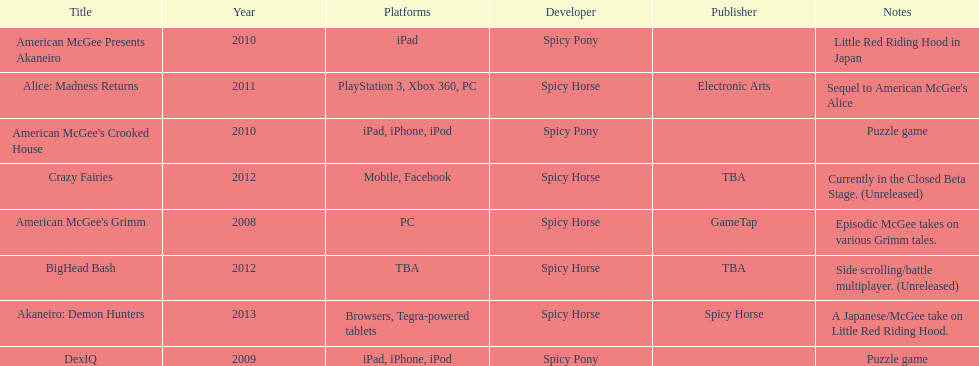Spicy pony released a total of three games; their game, "american mcgee's crooked house" was released on which platforms? Ipad, iphone, ipod. 